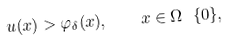<formula> <loc_0><loc_0><loc_500><loc_500>u ( x ) > \varphi _ { \delta } ( x ) , \quad x \in \Omega \ \{ 0 \} ,</formula> 